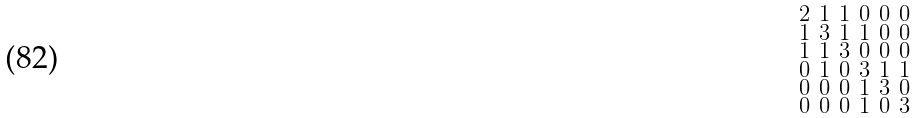<formula> <loc_0><loc_0><loc_500><loc_500>\begin{smallmatrix} 2 & 1 & 1 & 0 & 0 & 0 \\ 1 & 3 & 1 & 1 & 0 & 0 \\ 1 & 1 & 3 & 0 & 0 & 0 \\ 0 & 1 & 0 & 3 & 1 & 1 \\ 0 & 0 & 0 & 1 & 3 & 0 \\ 0 & 0 & 0 & 1 & 0 & 3 \end{smallmatrix}</formula> 